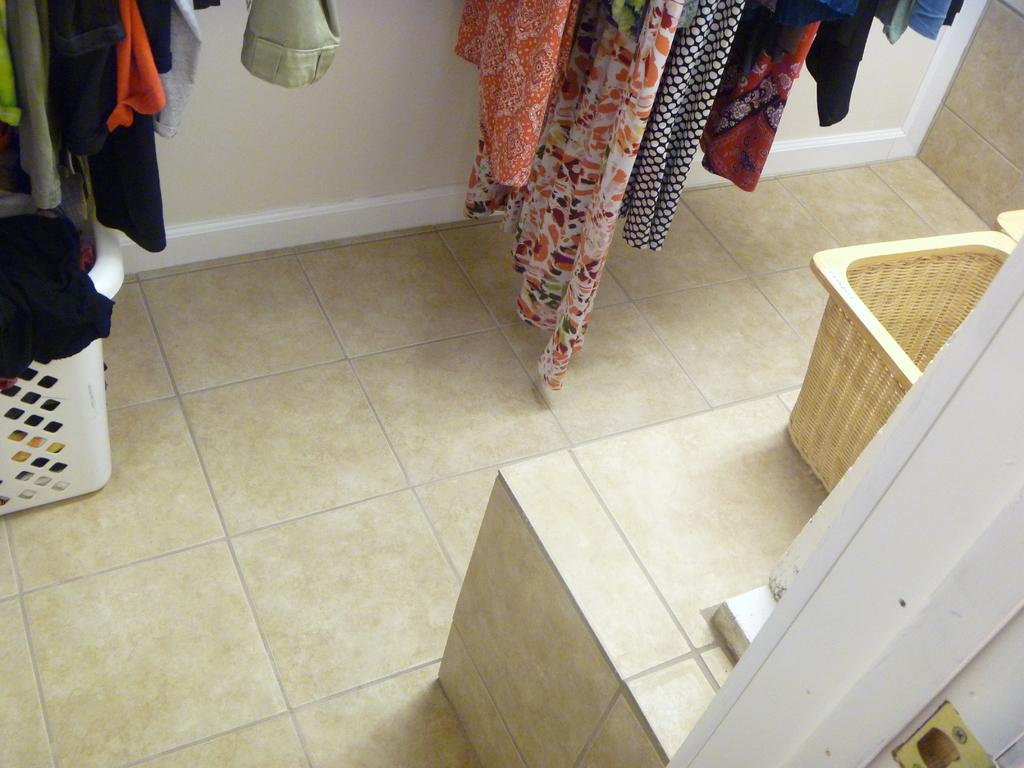What objects are in the foreground of the image? There are baskets in the foreground of the image. What is the purpose of the objects hanging on the wall in the image? Clothes are hanged on a wall in the image. Where was the image taken? The image was taken in a room. What type of truck is parked outside the room in the image? There is no truck visible in the image; it is taken inside a room with baskets and clothes hanging on a wall. 